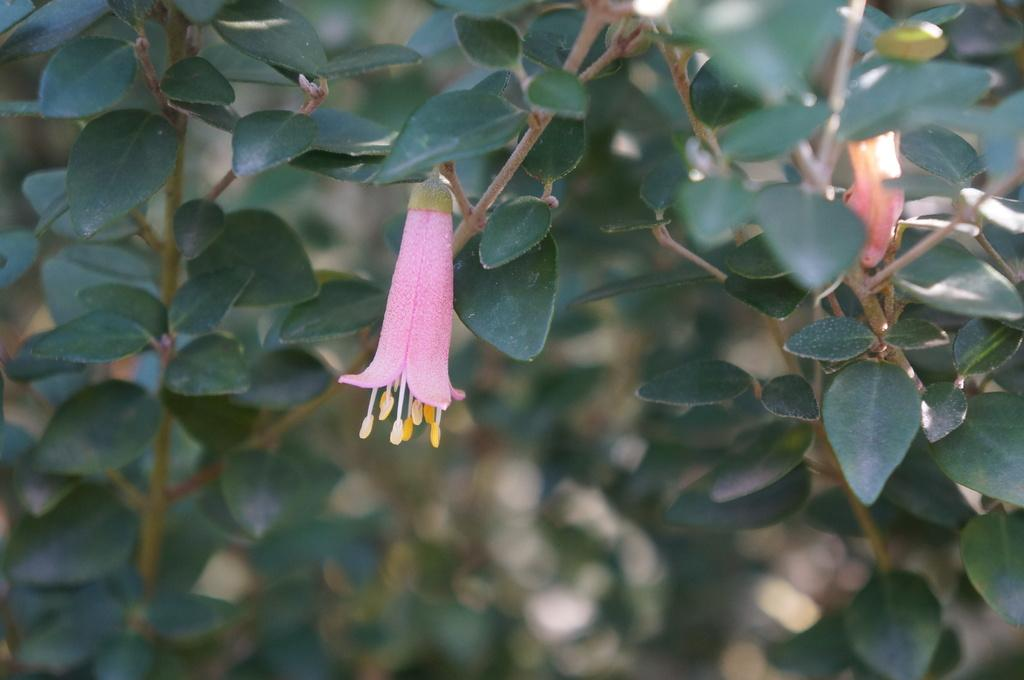What is the main subject of the image? There is a small pink flower in the middle of the image. Can you describe the flower in the image? The flower is small and pink. What else can be seen in the background of the image? There are plants in the background of the image. What type of argument is taking place between the plants in the background? There is no argument taking place between the plants in the background, as they are inanimate objects and cannot engage in arguments. 